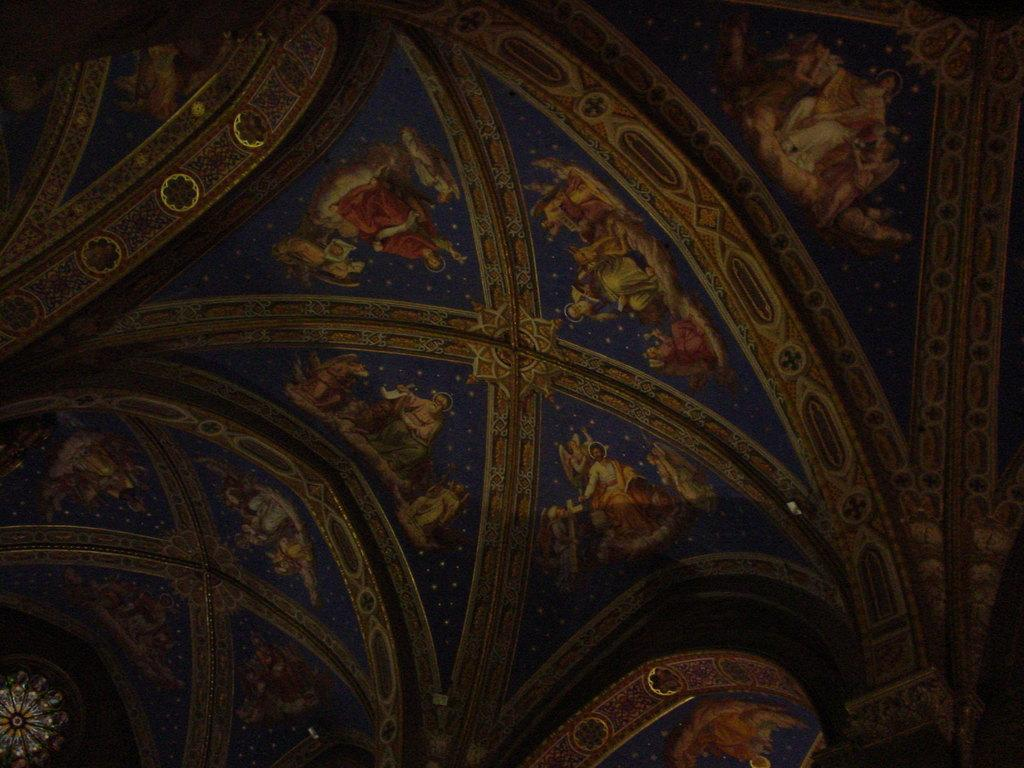What is the main subject of the image? The main subject of the image is different pictures. Can you see any cracks in the cave where the pictures are displayed? There is no mention of a cave in the provided fact, so it cannot be determined if there are any cracks in a cave. 